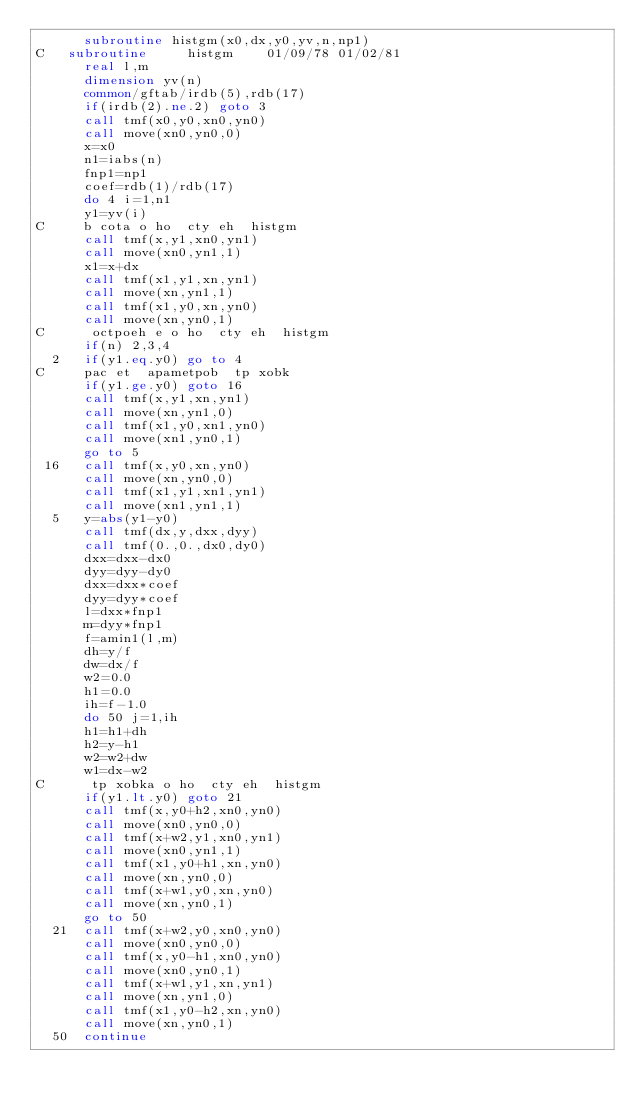Convert code to text. <code><loc_0><loc_0><loc_500><loc_500><_FORTRAN_>      subroutine histgm(x0,dx,y0,yv,n,np1)
C   subroutine     histgm    01/09/78 01/02/81
      real l,m
      dimension yv(n)
      common/gftab/irdb(5),rdb(17)
      if(irdb(2).ne.2) goto 3
      call tmf(x0,y0,xn0,yn0)
      call move(xn0,yn0,0)
      x=x0
      n1=iabs(n)
      fnp1=np1
      coef=rdb(1)/rdb(17)
      do 4 i=1,n1
      y1=yv(i)
C     b cota o ho  cty eh  histgm
      call tmf(x,y1,xn0,yn1)
      call move(xn0,yn1,1)
      x1=x+dx
      call tmf(x1,y1,xn,yn1)
      call move(xn,yn1,1)
      call tmf(x1,y0,xn,yn0)
      call move(xn,yn0,1)
C      octpoeh e o ho  cty eh  histgm
      if(n) 2,3,4
  2   if(y1.eq.y0) go to 4
C     pac et  apametpob  tp xobk
      if(y1.ge.y0) goto 16
      call tmf(x,y1,xn,yn1)
      call move(xn,yn1,0)
      call tmf(x1,y0,xn1,yn0)
      call move(xn1,yn0,1)
      go to 5
 16   call tmf(x,y0,xn,yn0)
      call move(xn,yn0,0)
      call tmf(x1,y1,xn1,yn1)
      call move(xn1,yn1,1)
  5   y=abs(y1-y0)
      call tmf(dx,y,dxx,dyy)
      call tmf(0.,0.,dx0,dy0)
      dxx=dxx-dx0
      dyy=dyy-dy0
      dxx=dxx*coef
      dyy=dyy*coef
      l=dxx*fnp1
      m=dyy*fnp1
      f=amin1(l,m)
      dh=y/f
      dw=dx/f
      w2=0.0
      h1=0.0
      ih=f-1.0
      do 50 j=1,ih
      h1=h1+dh
      h2=y-h1
      w2=w2+dw
      w1=dx-w2
C      tp xobka o ho  cty eh  histgm
      if(y1.lt.y0) goto 21
      call tmf(x,y0+h2,xn0,yn0)
      call move(xn0,yn0,0)
      call tmf(x+w2,y1,xn0,yn1)
      call move(xn0,yn1,1)
      call tmf(x1,y0+h1,xn,yn0)
      call move(xn,yn0,0)
      call tmf(x+w1,y0,xn,yn0)
      call move(xn,yn0,1)
      go to 50
  21  call tmf(x+w2,y0,xn0,yn0)
      call move(xn0,yn0,0)
      call tmf(x,y0-h1,xn0,yn0)
      call move(xn0,yn0,1)
      call tmf(x+w1,y1,xn,yn1)
      call move(xn,yn1,0)
      call tmf(x1,y0-h2,xn,yn0)
      call move(xn,yn0,1)
  50  continue</code> 